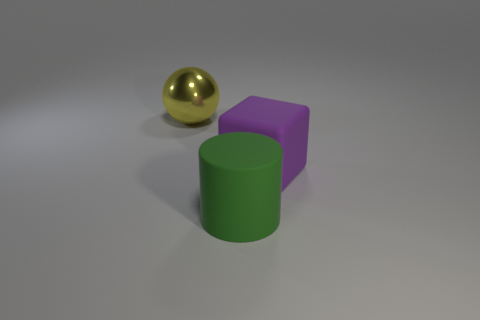Add 1 big purple objects. How many objects exist? 4 Subtract all blocks. How many objects are left? 2 Subtract all green cubes. Subtract all purple balls. How many cubes are left? 1 Subtract all tiny gray shiny blocks. Subtract all rubber cylinders. How many objects are left? 2 Add 3 yellow spheres. How many yellow spheres are left? 4 Add 1 purple rubber cubes. How many purple rubber cubes exist? 2 Subtract 0 green blocks. How many objects are left? 3 